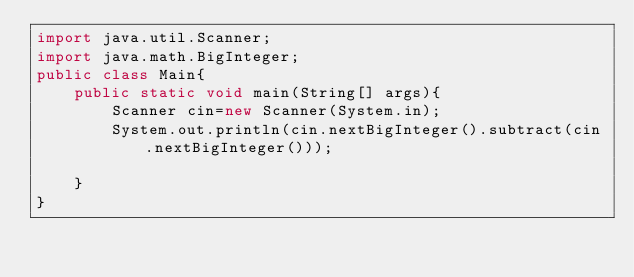<code> <loc_0><loc_0><loc_500><loc_500><_Java_>import java.util.Scanner;
import java.math.BigInteger;
public class Main{
    public static void main(String[] args){
        Scanner cin=new Scanner(System.in);
        System.out.println(cin.nextBigInteger().subtract(cin.nextBigInteger()));
        
    }
}
</code> 